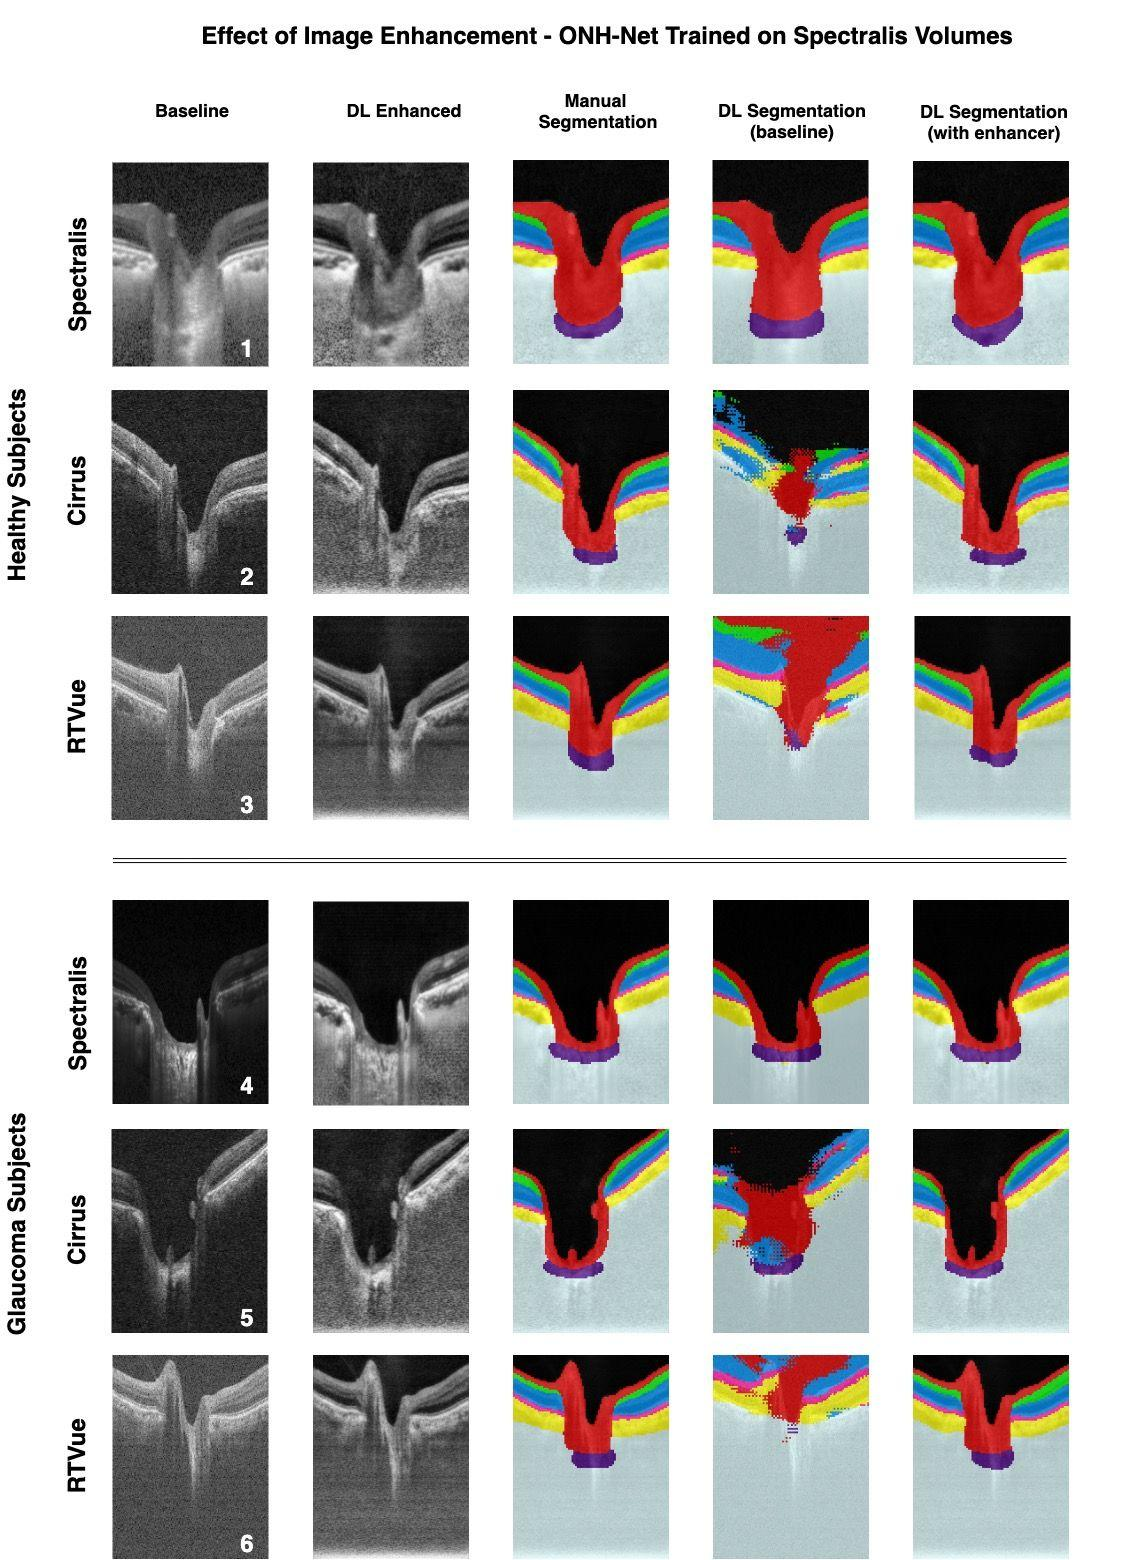How does the performance of the enhancement algorithm on Spectralis differ from that on Cirrus and RTVue OCT images? The performance of the enhancement algorithm can vary based on the characteristics of the OCT machines. For instance, the Spectralis system captures high-resolution images, and the algorithm may refine these with more subtle enhancements, sharpening details that are already quite clear. Contrastingly, Cirrus and RTVue images might benefit more markedly from the enhancement, as their baseline images could be of lower resolution or higher noise levels to start with. Thus, we could see a greater overall improvement in the visibility of the retinal layers and segmentation accuracy for Cirrus and RTVue compared to Spectralis after the application of the DL enhancement algorithm. 